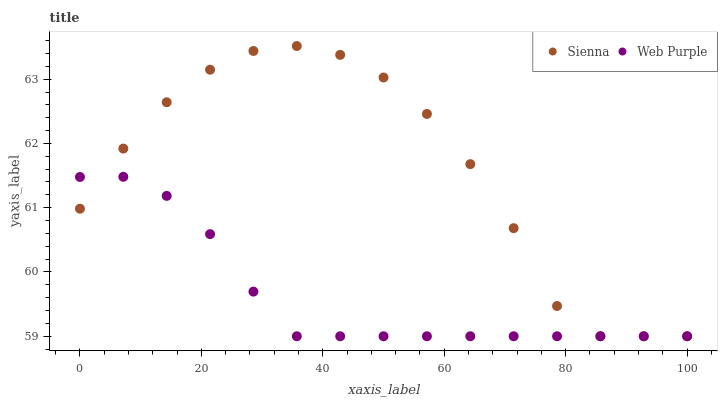Does Web Purple have the minimum area under the curve?
Answer yes or no. Yes. Does Sienna have the maximum area under the curve?
Answer yes or no. Yes. Does Web Purple have the maximum area under the curve?
Answer yes or no. No. Is Web Purple the smoothest?
Answer yes or no. Yes. Is Sienna the roughest?
Answer yes or no. Yes. Is Web Purple the roughest?
Answer yes or no. No. Does Sienna have the lowest value?
Answer yes or no. Yes. Does Sienna have the highest value?
Answer yes or no. Yes. Does Web Purple have the highest value?
Answer yes or no. No. Does Web Purple intersect Sienna?
Answer yes or no. Yes. Is Web Purple less than Sienna?
Answer yes or no. No. Is Web Purple greater than Sienna?
Answer yes or no. No. 